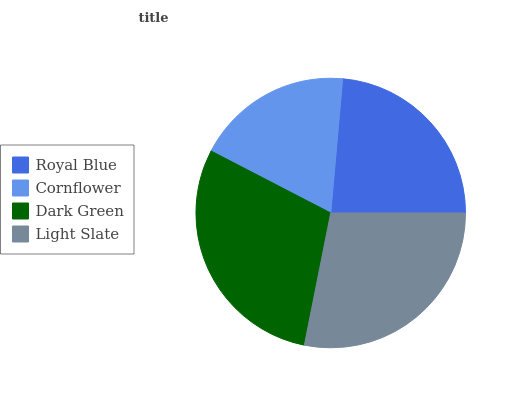Is Cornflower the minimum?
Answer yes or no. Yes. Is Dark Green the maximum?
Answer yes or no. Yes. Is Dark Green the minimum?
Answer yes or no. No. Is Cornflower the maximum?
Answer yes or no. No. Is Dark Green greater than Cornflower?
Answer yes or no. Yes. Is Cornflower less than Dark Green?
Answer yes or no. Yes. Is Cornflower greater than Dark Green?
Answer yes or no. No. Is Dark Green less than Cornflower?
Answer yes or no. No. Is Light Slate the high median?
Answer yes or no. Yes. Is Royal Blue the low median?
Answer yes or no. Yes. Is Royal Blue the high median?
Answer yes or no. No. Is Light Slate the low median?
Answer yes or no. No. 